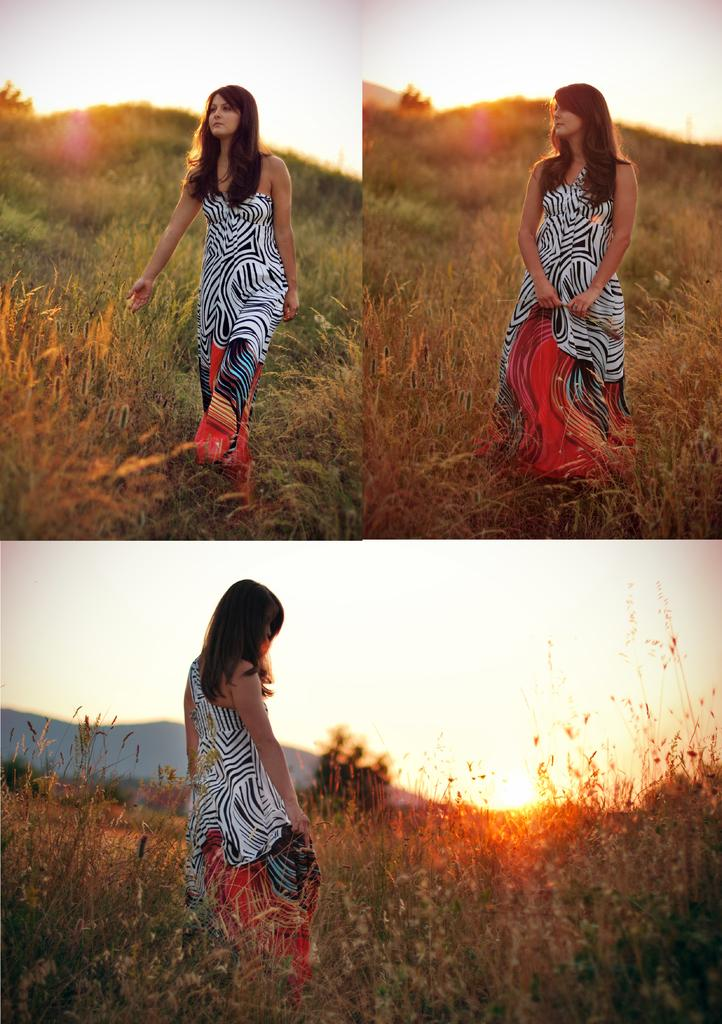How many pictures are present in the image? There are three pictures in the image. What do the pictures have in common? Each picture contains a woman wearing a black dress. What is the woman doing in each picture? The woman is walking on the grass in each picture. What can be seen in the background of the pictures? There are trees, hills, the sun, and the sky visible in the background of the pictures. What type of house can be seen in the background of the pictures? There is no house present in the background of the pictures; only trees, hills, the sun, and the sky are visible. 